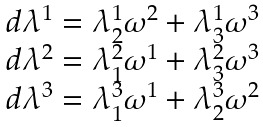Convert formula to latex. <formula><loc_0><loc_0><loc_500><loc_500>\begin{array} { l } d \lambda ^ { 1 } = \lambda ^ { 1 } _ { 2 } \omega ^ { 2 } + \lambda ^ { 1 } _ { 3 } \omega ^ { 3 } \\ d \lambda ^ { 2 } = \lambda ^ { 2 } _ { 1 } \omega ^ { 1 } + \lambda ^ { 2 } _ { 3 } \omega ^ { 3 } \\ d \lambda ^ { 3 } = \lambda ^ { 3 } _ { 1 } \omega ^ { 1 } + \lambda ^ { 3 } _ { 2 } \omega ^ { 2 } \\ \end{array}</formula> 